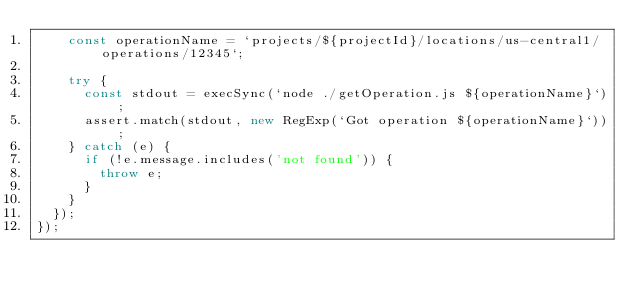Convert code to text. <code><loc_0><loc_0><loc_500><loc_500><_JavaScript_>    const operationName = `projects/${projectId}/locations/us-central1/operations/12345`;

    try {
      const stdout = execSync(`node ./getOperation.js ${operationName}`);
      assert.match(stdout, new RegExp(`Got operation ${operationName}`));
    } catch (e) {
      if (!e.message.includes('not found')) {
        throw e;
      }
    }
  });
});
</code> 